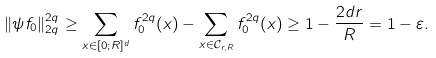<formula> <loc_0><loc_0><loc_500><loc_500>\| { \psi f _ { 0 } } \| ^ { 2 q } _ { 2 q } \geq \sum _ { x \in [ 0 ; R ] ^ { d } } f _ { 0 } ^ { 2 q } ( x ) - \sum _ { x \in \mathcal { C } _ { r , R } } f _ { 0 } ^ { 2 q } ( x ) \geq 1 - \frac { 2 d r } { R } = 1 - \varepsilon .</formula> 